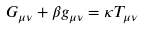Convert formula to latex. <formula><loc_0><loc_0><loc_500><loc_500>G _ { \mu \nu } + \beta g _ { \mu \nu } = \kappa T _ { \mu \nu }</formula> 